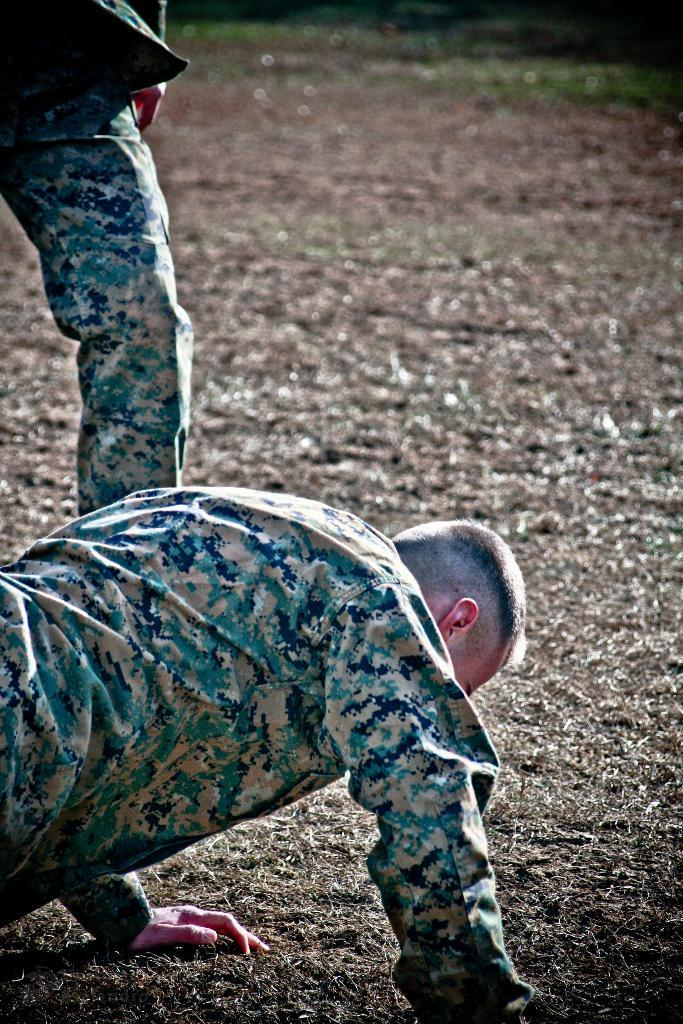What is the person in the image wearing? There is a person wearing a uniform in the image. Where is the person located in the image? The person is on the grass. Can you describe any other people in the image? Another person's leg is visible in the image. How would you describe the background of the image? The background of the image is slightly blurred. How many pizzas are being served to the family in the image? There is no family or pizzas present in the image. What type of joke is the person telling in the image? There is no joke being told in the image; the person is simply standing on the grass in a uniform. 